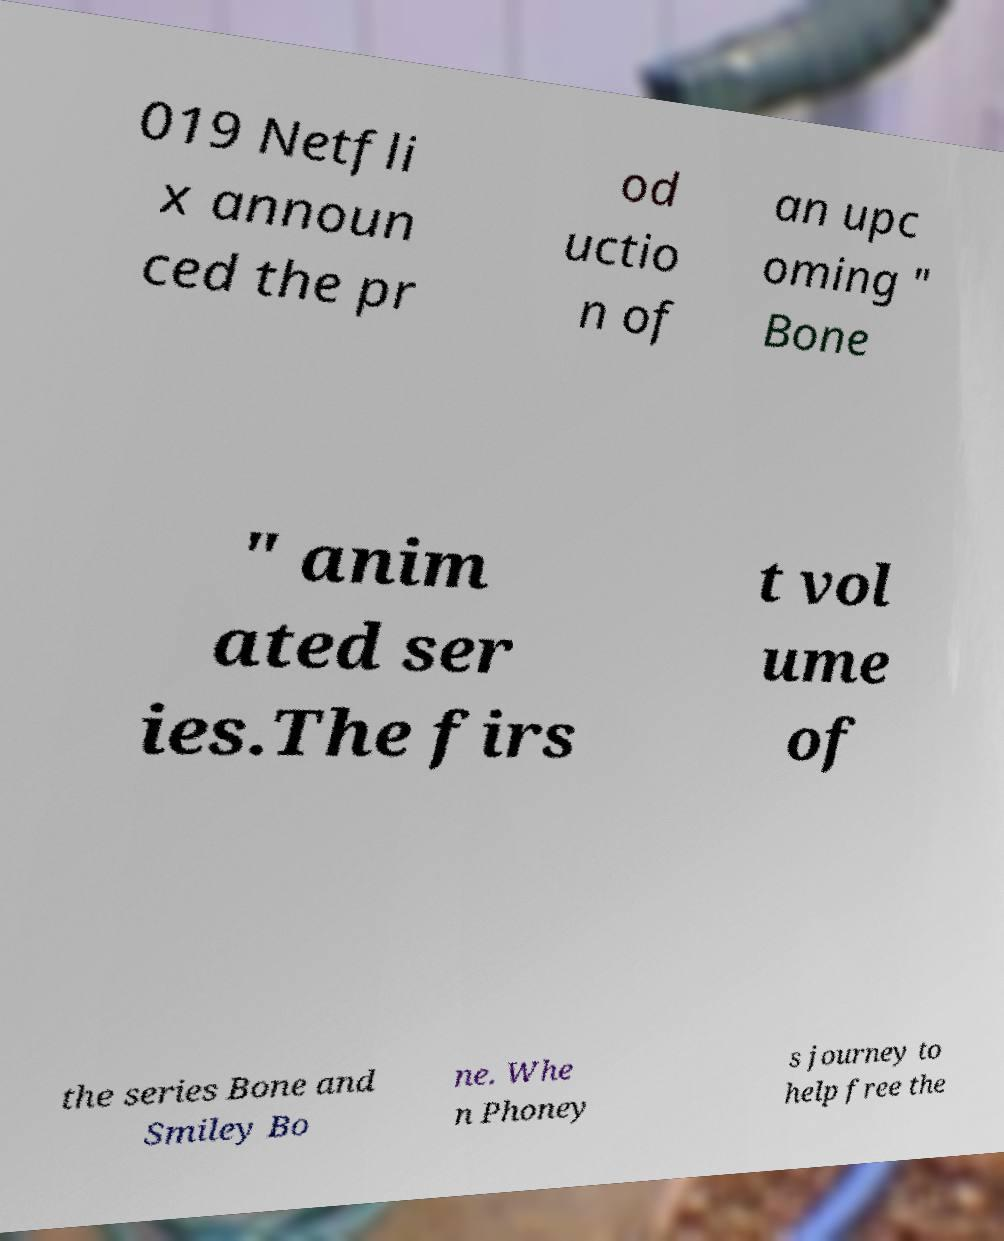Please read and relay the text visible in this image. What does it say? 019 Netfli x announ ced the pr od uctio n of an upc oming " Bone " anim ated ser ies.The firs t vol ume of the series Bone and Smiley Bo ne. Whe n Phoney s journey to help free the 